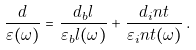Convert formula to latex. <formula><loc_0><loc_0><loc_500><loc_500>\frac { d } { \varepsilon ( \omega ) } = \frac { d _ { b } l } { \varepsilon _ { b } l ( \omega ) } + \frac { d _ { i } n t } { \varepsilon _ { i } n t ( \omega ) } \, .</formula> 